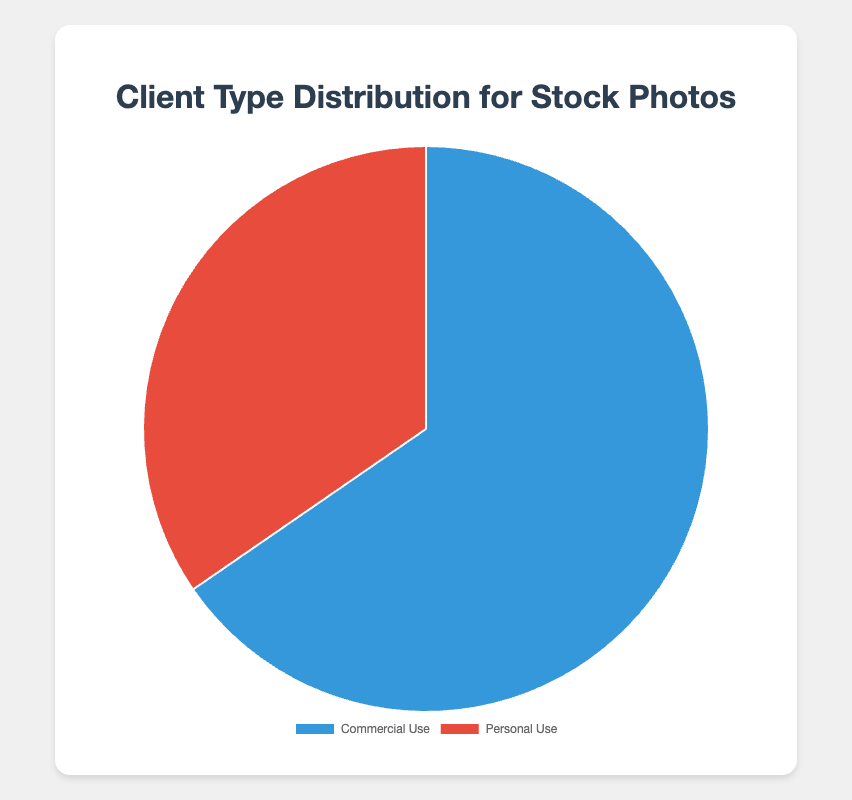What is the percentage of commercial use of stock photos? The figure shows that the percentage of commercial use of stock photos is indicated as a single data point.
Answer: 65.4% What is the percentage difference between commercial use and personal use of stock photos? To find the percentage difference, subtract the percentage of personal use from the percentage of commercial use: 65.4% - 34.6% = 30.8%.
Answer: 30.8% Which client type has the higher usage percentage? By comparing the two provided percentages, commercial use (65.4%) is higher than personal use (34.6%).
Answer: Commercial Use What is the total percentage of stock photos used by marketing agencies and corporate websites combined? Add the percentages for marketing agencies (30.2%) and corporate websites (20.1%): 30.2% + 20.1% = 50.3%.
Answer: 50.3% Which client entity under personal use has the highest usage percentage? The personal use entities are bloggers, social media influencers, and individuals. The highest percentage among these is bloggers at 12.7%.
Answer: Bloggers How much greater is the percentage of marketing agencies' usage compared to individuals? Subtract the percentage for individuals from the percentage for marketing agencies: 30.2% - 10.0% = 20.2%.
Answer: 20.2% What portion of the commercial use of stock photos is attributed to advertising firms? From the data points, advertising firms comprise 15.1% of the commercial use category.
Answer: 15.1% What is the average usage percentage of the entities under personal use? Sum the percentages of the personal use entities and divide by the number of entities: (12.7% + 11.9% + 10.0%) / 3 = 34.6% / 3 ≈ 11.53%.
Answer: 11.53% Is the percentage usage by corporate websites higher or lower than the combined usage by bloggers and social media influencers? Calculate the combined usage by bloggers and social media influencers: 12.7% + 11.9% = 24.6%. The corporate websites' usage is 20.1%, which is lower.
Answer: Lower 